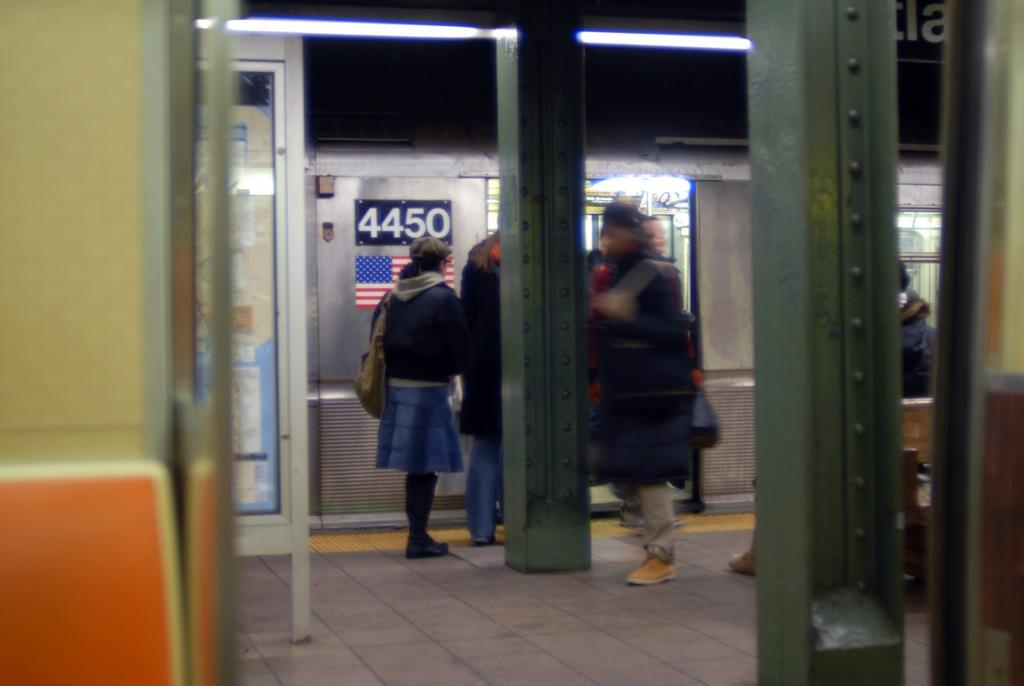What type of construction material can be seen in the image? There are iron beams in the image. What mode of transportation is visible in the image? There is a train visible in the image. What is the position of the people in relation to the train? There are people in front of the train. What additional information can be gathered from the train? There is text visible on the train. What type of mint is being grown in the image? There is no mint present in the image; it features iron beams, a train, and people. How many mittens can be seen on the people in the image? There is no mention of mittens in the image; the focus is on the iron beams, train, and people. 